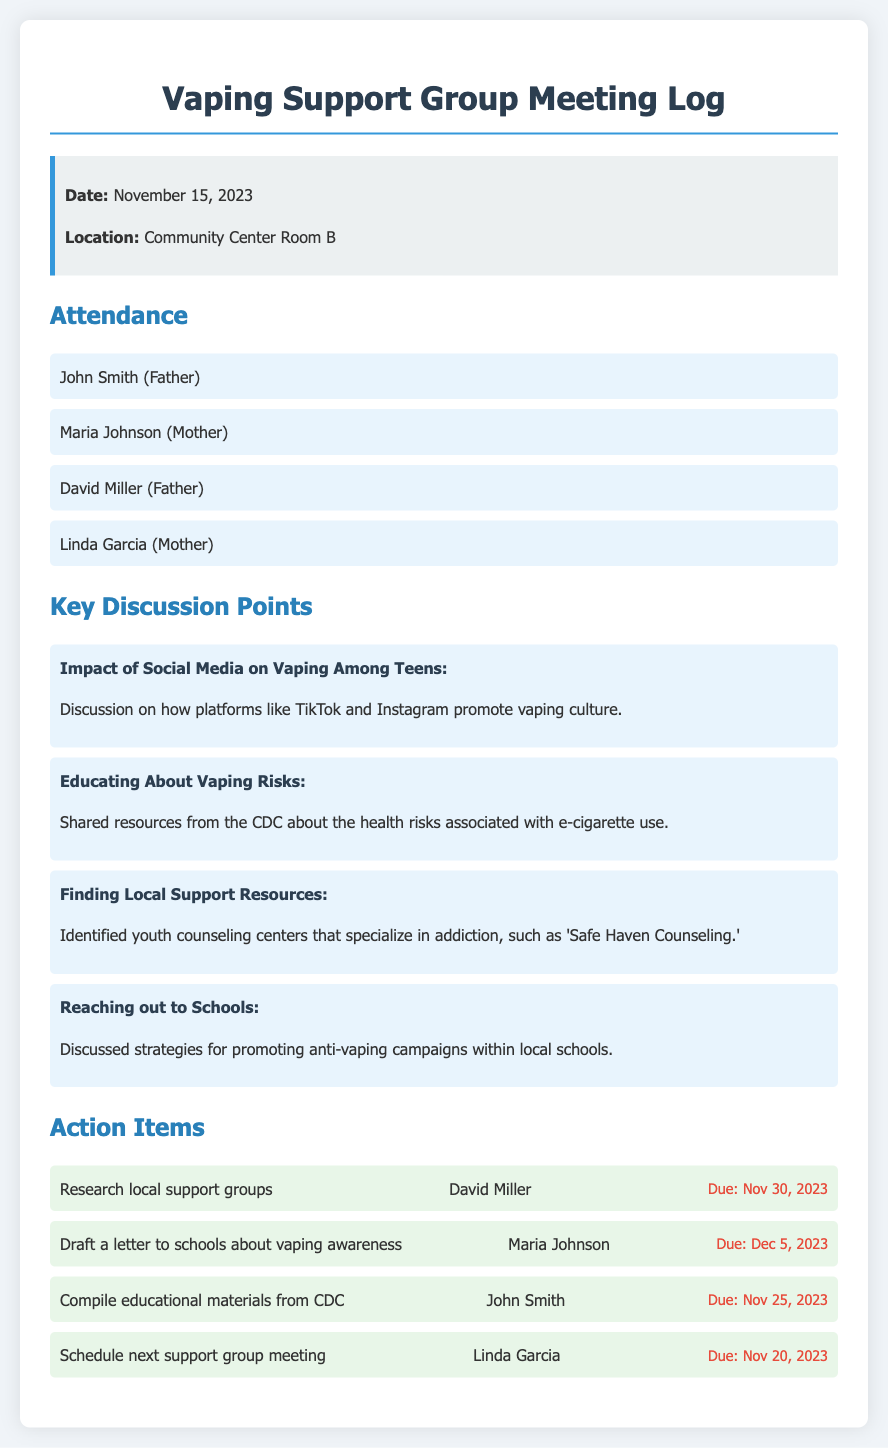What is the date of the meeting? The date of the meeting is explicitly stated in the document under the meeting info section.
Answer: November 15, 2023 How many parents attended the meeting? The number of parents can be found in the attendance section, where each parent's name is listed.
Answer: 4 What is one of the key discussion points? The discussion points are clearly listed in the key discussion points section; one example can be chosen.
Answer: Impact of Social Media on Vaping Among Teens Who is responsible for compiling educational materials from CDC? The action items section lists the individual responsible for each task.
Answer: John Smith What is the due date for the action item scheduled to draft a letter to schools? The due date is specified next to the respective action item in the action items section.
Answer: Dec 5, 2023 Which parent is tasked with researching local support groups? This information is contained within the action items section.
Answer: David Miller Where was the meeting held? The location is given under the meeting info section of the document.
Answer: Community Center Room B What resource was shared regarding the risks associated with vaping? The document indicates a specific resource in the discussion points section.
Answer: CDC 